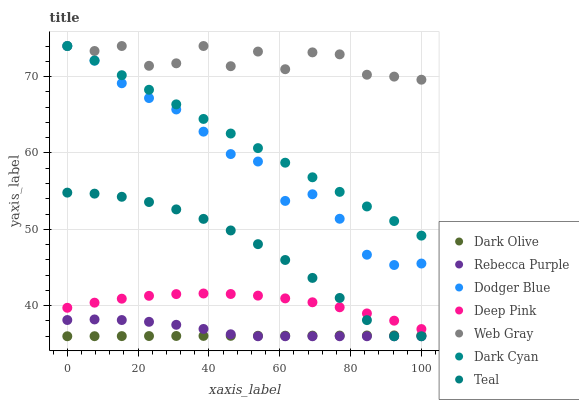Does Dark Olive have the minimum area under the curve?
Answer yes or no. Yes. Does Web Gray have the maximum area under the curve?
Answer yes or no. Yes. Does Deep Pink have the minimum area under the curve?
Answer yes or no. No. Does Deep Pink have the maximum area under the curve?
Answer yes or no. No. Is Dark Cyan the smoothest?
Answer yes or no. Yes. Is Web Gray the roughest?
Answer yes or no. Yes. Is Dark Olive the smoothest?
Answer yes or no. No. Is Dark Olive the roughest?
Answer yes or no. No. Does Dark Olive have the lowest value?
Answer yes or no. Yes. Does Deep Pink have the lowest value?
Answer yes or no. No. Does Dark Cyan have the highest value?
Answer yes or no. Yes. Does Deep Pink have the highest value?
Answer yes or no. No. Is Dark Olive less than Dodger Blue?
Answer yes or no. Yes. Is Dodger Blue greater than Deep Pink?
Answer yes or no. Yes. Does Dark Cyan intersect Dodger Blue?
Answer yes or no. Yes. Is Dark Cyan less than Dodger Blue?
Answer yes or no. No. Is Dark Cyan greater than Dodger Blue?
Answer yes or no. No. Does Dark Olive intersect Dodger Blue?
Answer yes or no. No. 